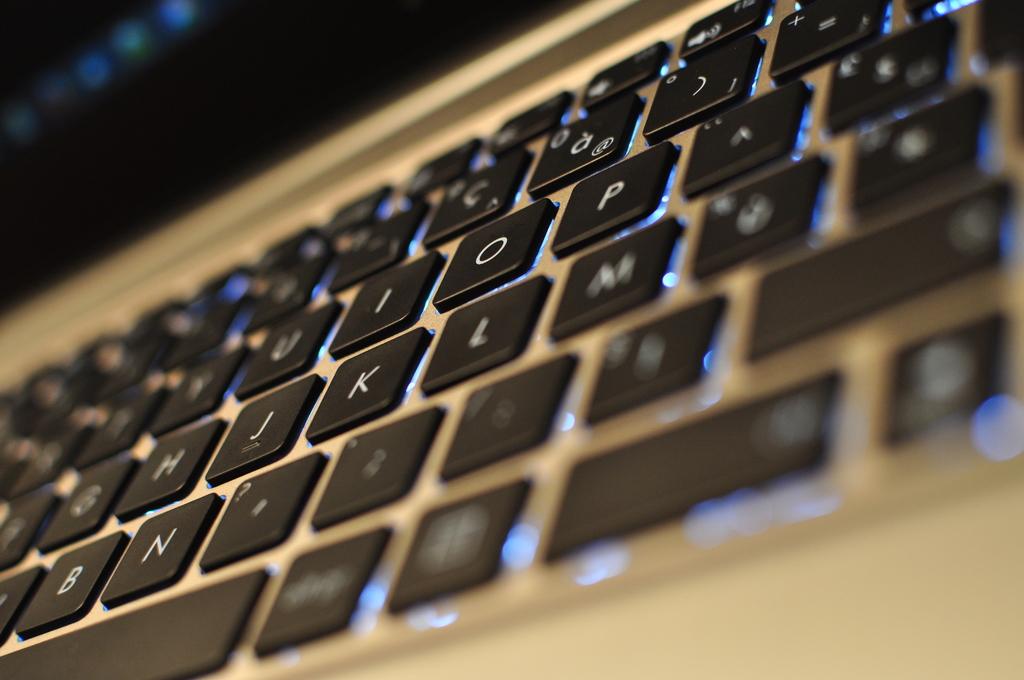What letter is to the right of k?
Your response must be concise. L. What letter is to the left of n?
Your response must be concise. B. 